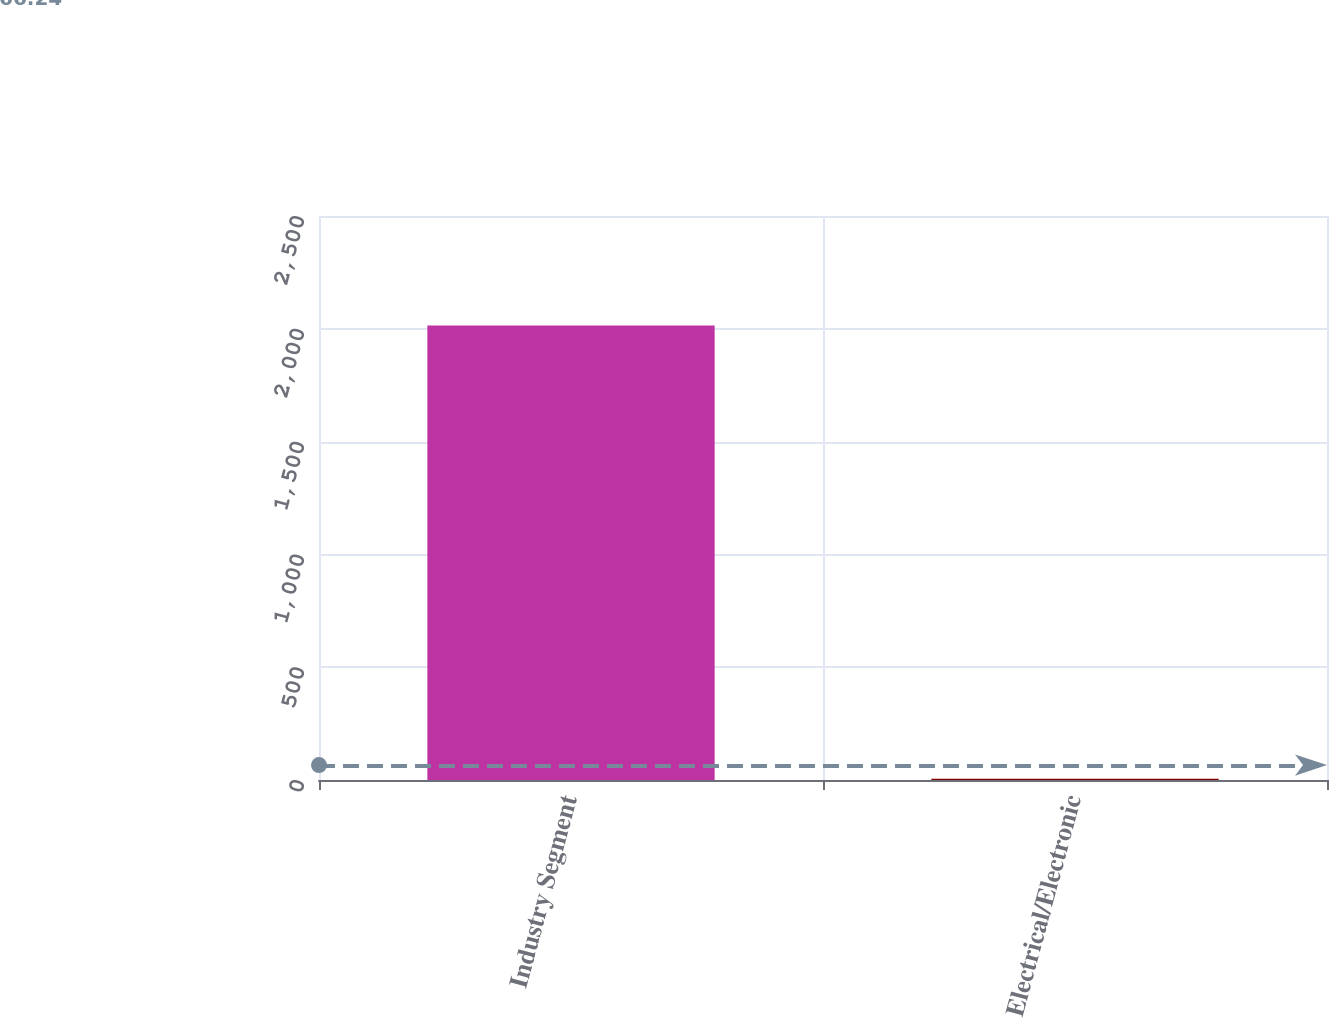Convert chart to OTSL. <chart><loc_0><loc_0><loc_500><loc_500><bar_chart><fcel>Industry Segment<fcel>Electrical/Electronic<nl><fcel>2015<fcel>5<nl></chart> 